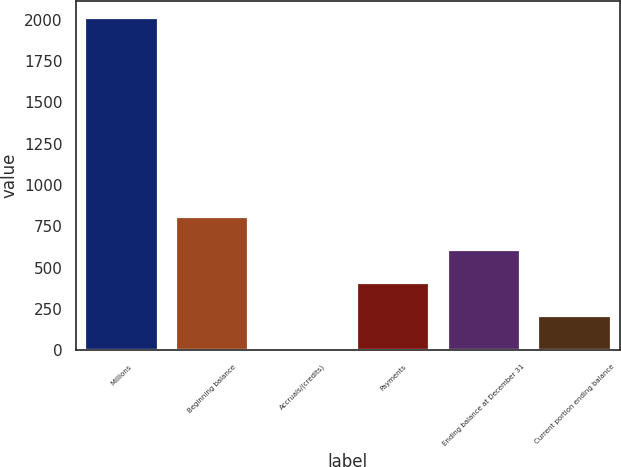<chart> <loc_0><loc_0><loc_500><loc_500><bar_chart><fcel>Millions<fcel>Beginning balance<fcel>Accruals/(credits)<fcel>Payments<fcel>Ending balance at December 31<fcel>Current portion ending balance<nl><fcel>2011<fcel>807.4<fcel>5<fcel>406.2<fcel>606.8<fcel>205.6<nl></chart> 